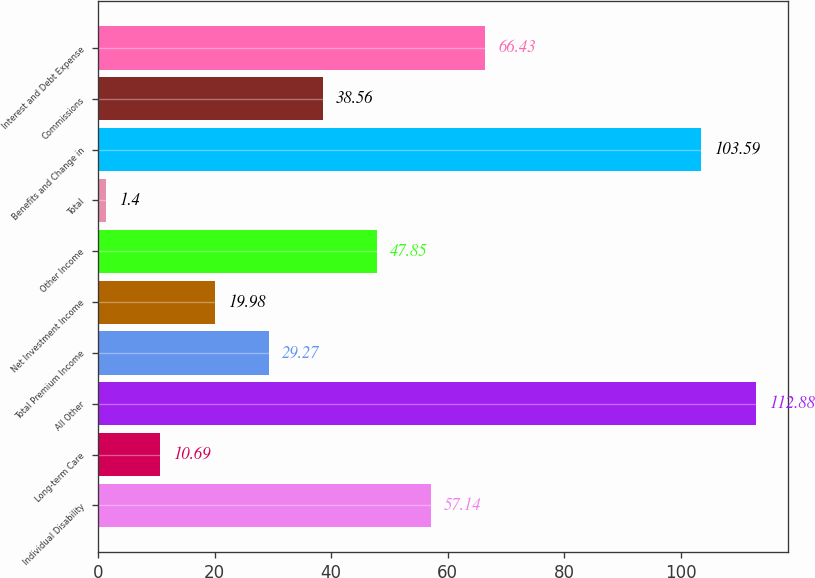Convert chart to OTSL. <chart><loc_0><loc_0><loc_500><loc_500><bar_chart><fcel>Individual Disability<fcel>Long-term Care<fcel>All Other<fcel>Total Premium Income<fcel>Net Investment Income<fcel>Other Income<fcel>Total<fcel>Benefits and Change in<fcel>Commissions<fcel>Interest and Debt Expense<nl><fcel>57.14<fcel>10.69<fcel>112.88<fcel>29.27<fcel>19.98<fcel>47.85<fcel>1.4<fcel>103.59<fcel>38.56<fcel>66.43<nl></chart> 